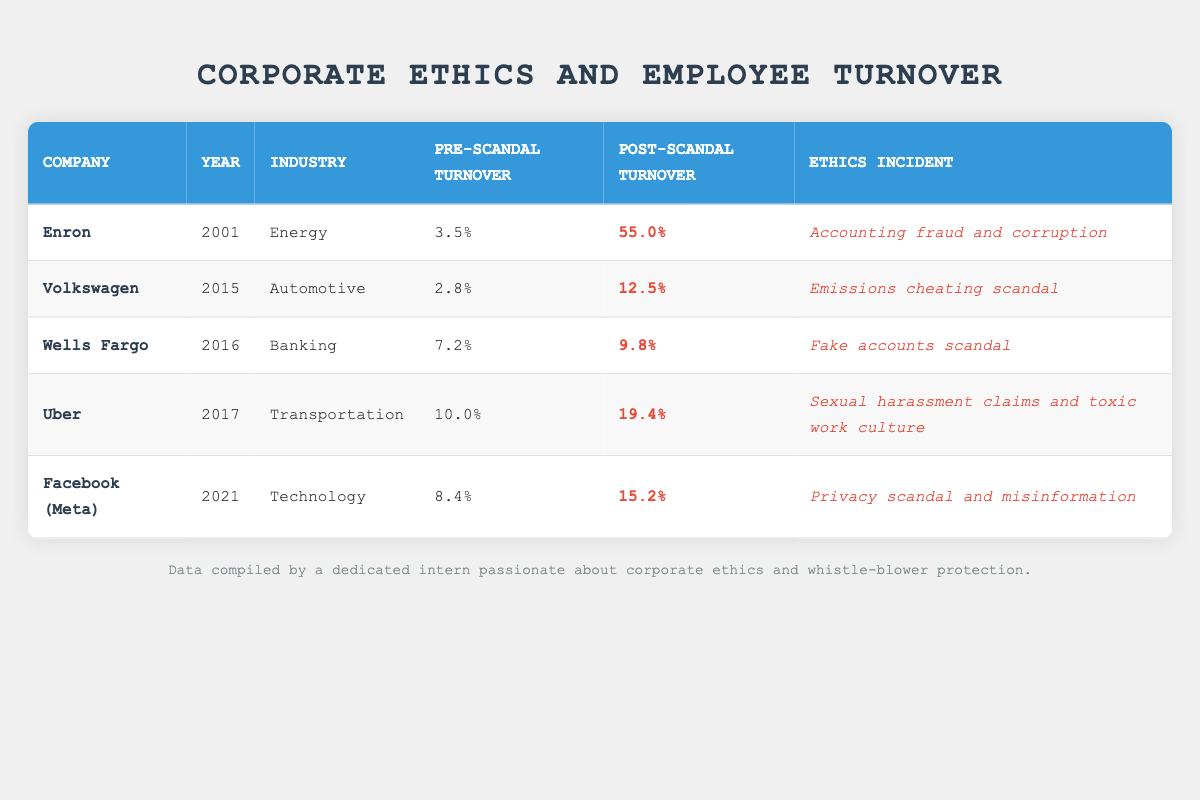What was Enron's pre-scandal turnover rate? According to the table, Enron's pre-scandal turnover rate is specified as 3.5%. Therefore, we can find this value directly from the corresponding row in the table.
Answer: 3.5% What year did the Volkswagen emissions cheating scandal occur? The table shows that the emissions cheating scandal involving Volkswagen took place in 2015, as indicated in the corresponding row.
Answer: 2015 Which company had the highest post-scandal turnover rate? To find the company with the highest post-scandal turnover rate, we need to look at the post-scandal figures for each company. Comparing them shows that Enron had the highest rate at 55.0%.
Answer: Enron What is the difference in turnover rates for Wells Fargo before and after the scandal? For Wells Fargo, the pre-scandal turnover rate is 7.2% and the post-scandal rate is 9.8%. The difference can be calculated as 9.8% - 7.2% = 2.6%.
Answer: 2.6% Was the turnover rate for Uber after the scandal higher than 15%? The post-scandal turnover rate for Uber is listed as 19.4%. Since 19.4% is higher than 15%, the answer to this question is yes.
Answer: Yes What is the average pre-scandal turnover rate for the companies listed? First, we add the pre-scandal rates: 3.5 + 2.8 + 7.2 + 10.0 + 8.4 = 32.9%. Then we divide by the number of companies (5) to get the average: 32.9% / 5 = 6.58%.
Answer: 6.58% Which ethical incident corresponds to the lowest post-scandal turnover rate? Looking at the table, Wells Fargo has the lowest post-scandal turnover rate at 9.8%, which corresponds to the fake accounts scandal. Thus, that is the answer to the question.
Answer: Fake accounts scandal How many companies had a post-scandal turnover rate above 15%? Referring to the table, we can count the companies with post-scandal turnover rates: Enron (55.0%), Uber (19.4%), and Facebook (Meta) (15.2%). Therefore, three companies exceed 15%.
Answer: 3 Did any company have a lower post-scandal turnover rate than their pre-scandal rate? By analyzing the table, we find that all listed companies have a post-scandal turnover rate that is higher than their pre-scandal rate; therefore, the answer is no.
Answer: No 